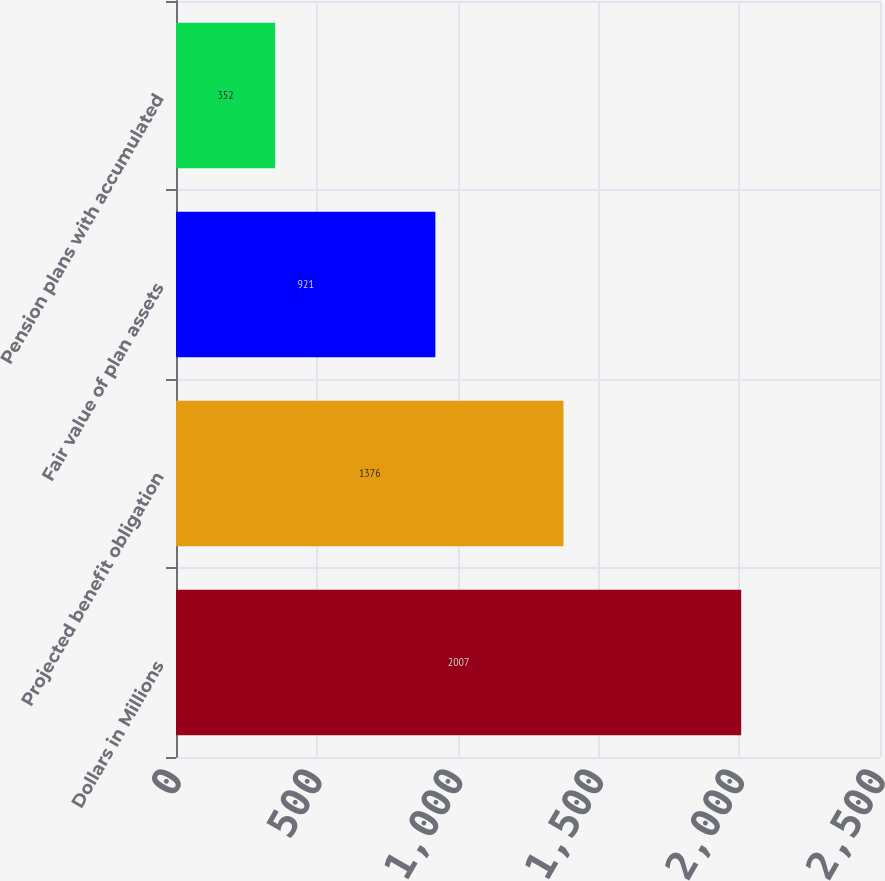Convert chart to OTSL. <chart><loc_0><loc_0><loc_500><loc_500><bar_chart><fcel>Dollars in Millions<fcel>Projected benefit obligation<fcel>Fair value of plan assets<fcel>Pension plans with accumulated<nl><fcel>2007<fcel>1376<fcel>921<fcel>352<nl></chart> 